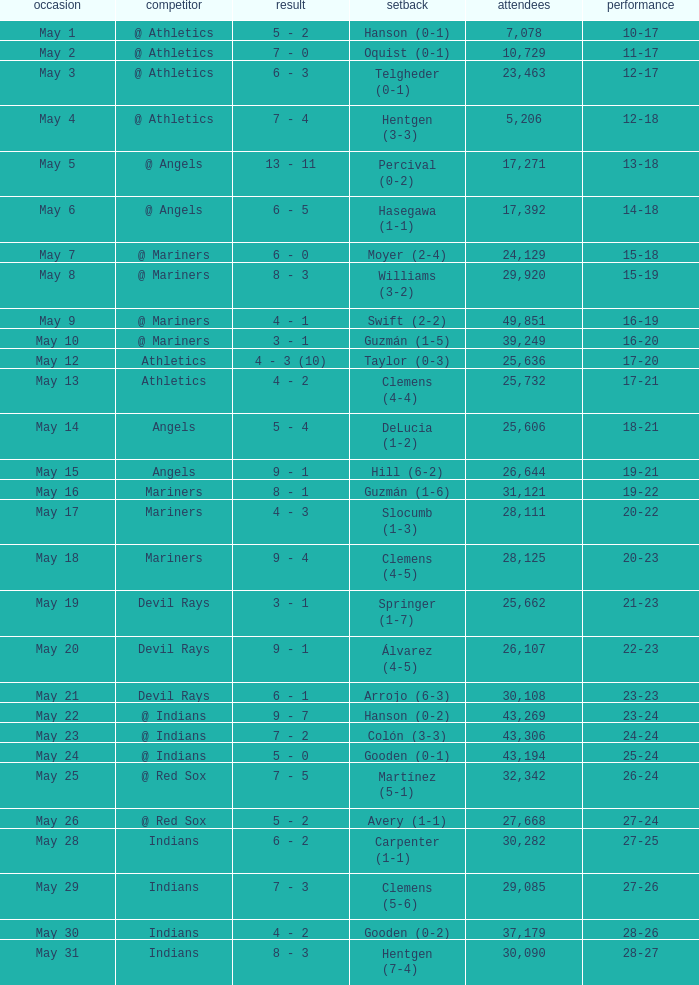For record 25-24, what is the sum of attendance? 1.0. 